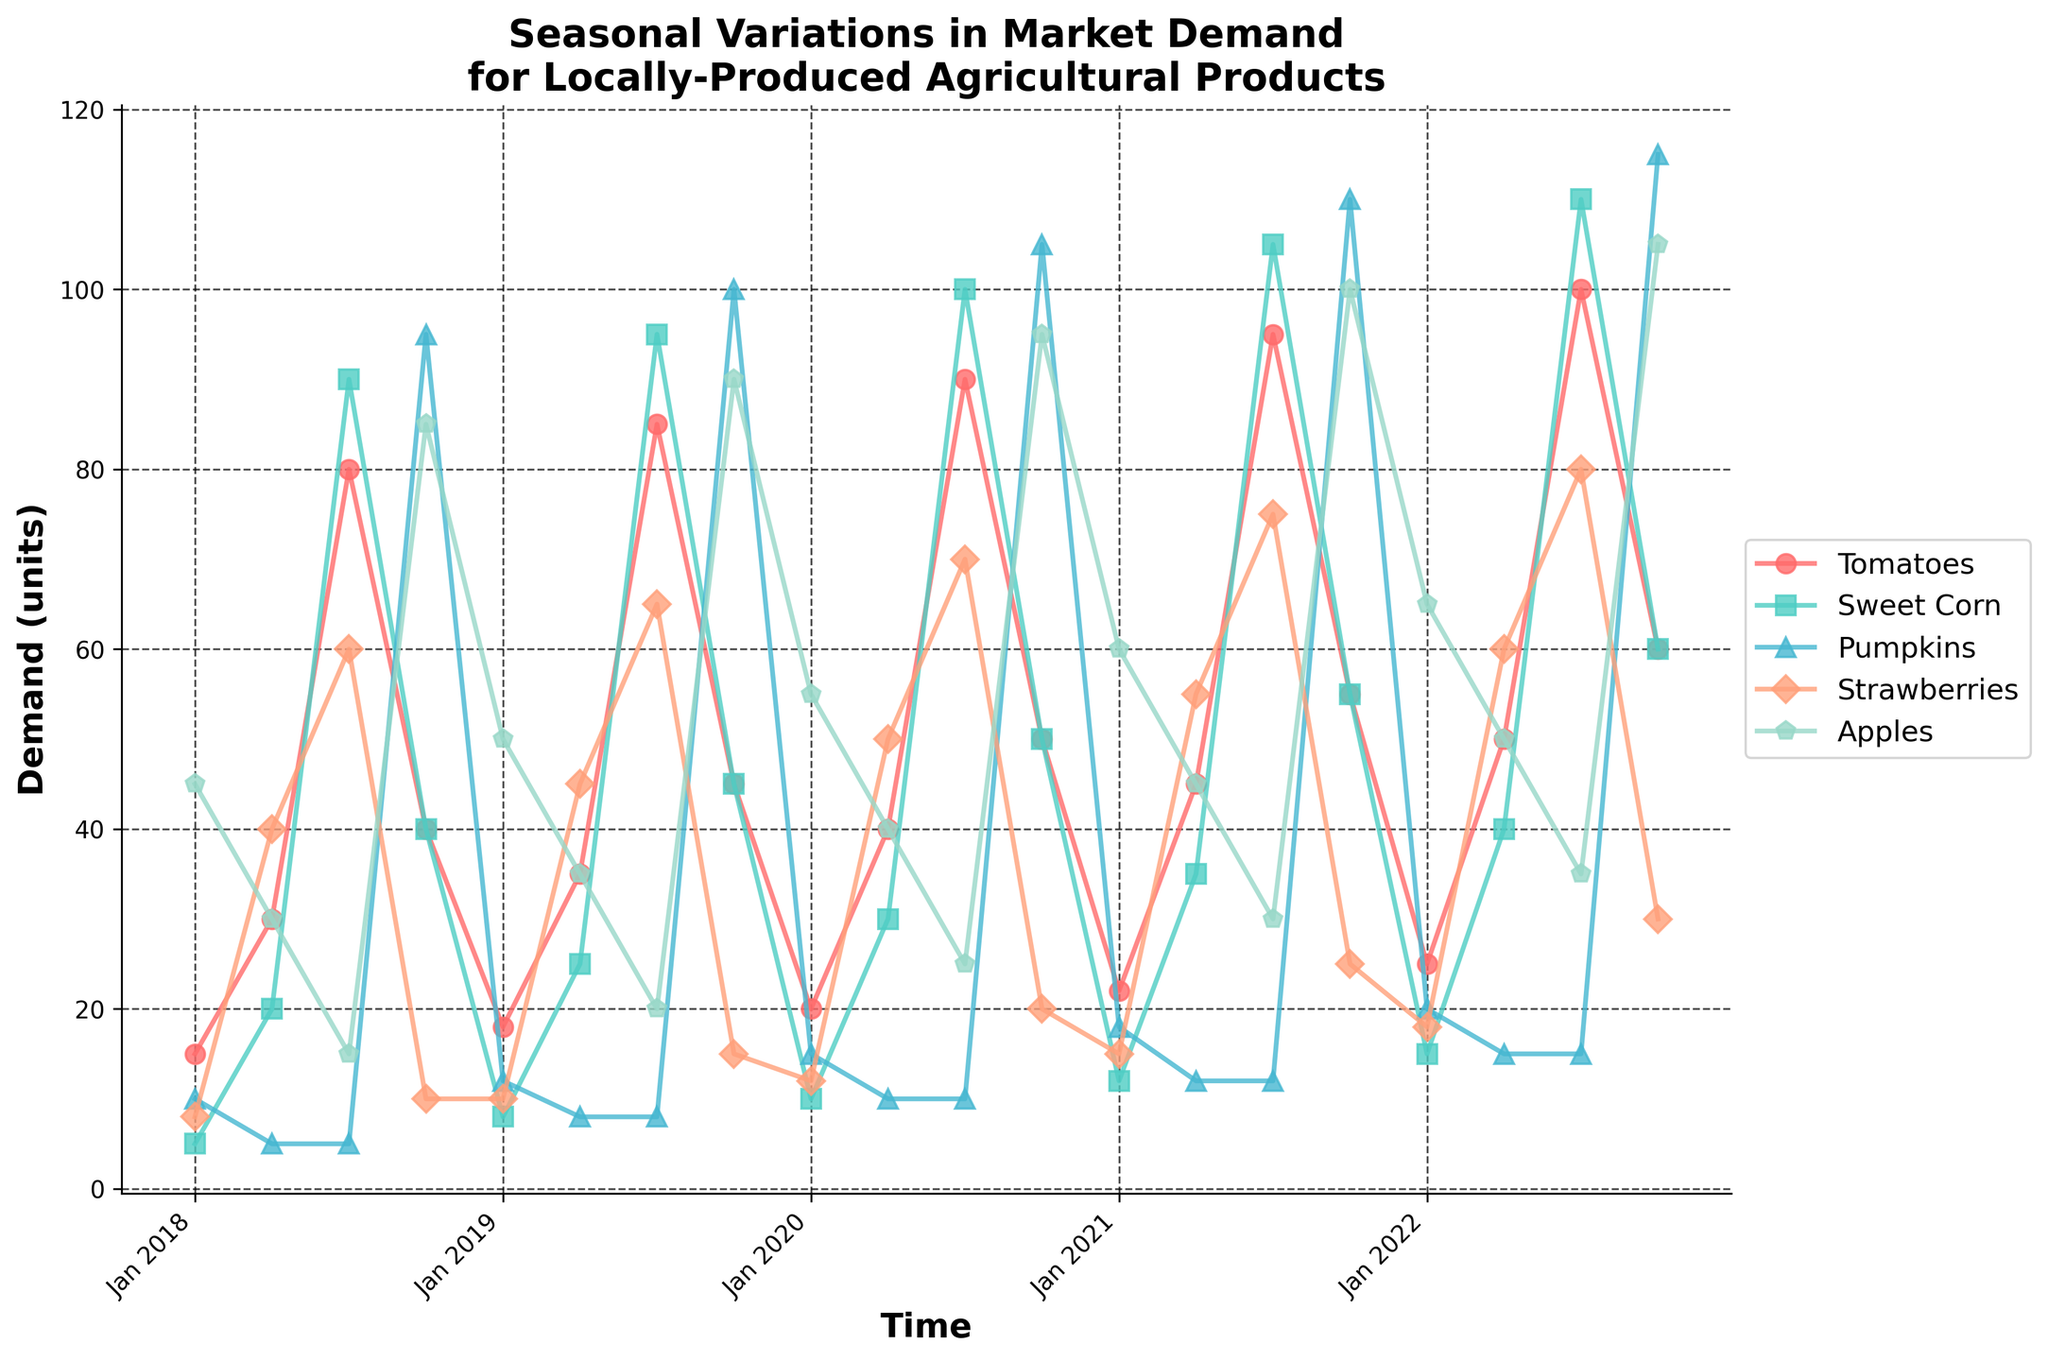What crop shows the highest demand in October 2020? Look for the peaks in October 2020 and note the value for each crop. Pumpkins have the highest demand at 105 units.
Answer: Pumpkins Which crop has the least variation in demand over the years? Examine the range of values for each crop. Strawberries have the smallest range (8 to 80 units).
Answer: Strawberries In which month and year did Tomatoes reach their peak demand? Trace the line for Tomatoes and find the highest point. Tomatoes peak in July 2022 with demand reaching 100 units.
Answer: July 2022 What is the average demand for Apples in the month of April over the 5-year period? Collect values for Apples in April (30, 35, 40, 45, 50). Calculate the average: (30+35+40+45+50) / 5 = 40 units.
Answer: 40 units Compare the demand for Sweet Corn and Strawberries in July 2019. Which one is higher? Look at the demand values in July 2019 for both Sweet Corn (95) and Strawberries (65). Sweet Corn has higher demand.
Answer: Sweet Corn How much did the demand for Pumpkins increase from Jan 2020 to Oct 2022? Find the demand for Pumpkins in Jan 2020 (15) and Oct 2022 (115). Calculate the difference: 115 - 15 = 100 units.
Answer: 100 units What is the trend observed for Strawberries from Jan 2018 to Jan 2022? Follow the trend line for Strawberries. The trend shows an overall increase from 8 to 18 units over the period.
Answer: Increasing Which crop shows the largest drop in demand from one month to the next within the same year? Examine all drops between consecutive months for each year. The largest drop is for Tomatoes from July 2019 (85) to October 2019 (45), a decrease by 40 units.
Answer: Tomatoes In October 2021, how does the demand for Pumpkins compare to Apples? Check the values for both crops in October 2021. Pumpkins have a demand of 110 units, higher than Apples at 100 units.
Answer: Pumpkins What was the peak demand observed for Sweet Corn over the entire period? Identify the highest point on Sweet Corn's line, which is 110 units in July 2022.
Answer: 110 units 